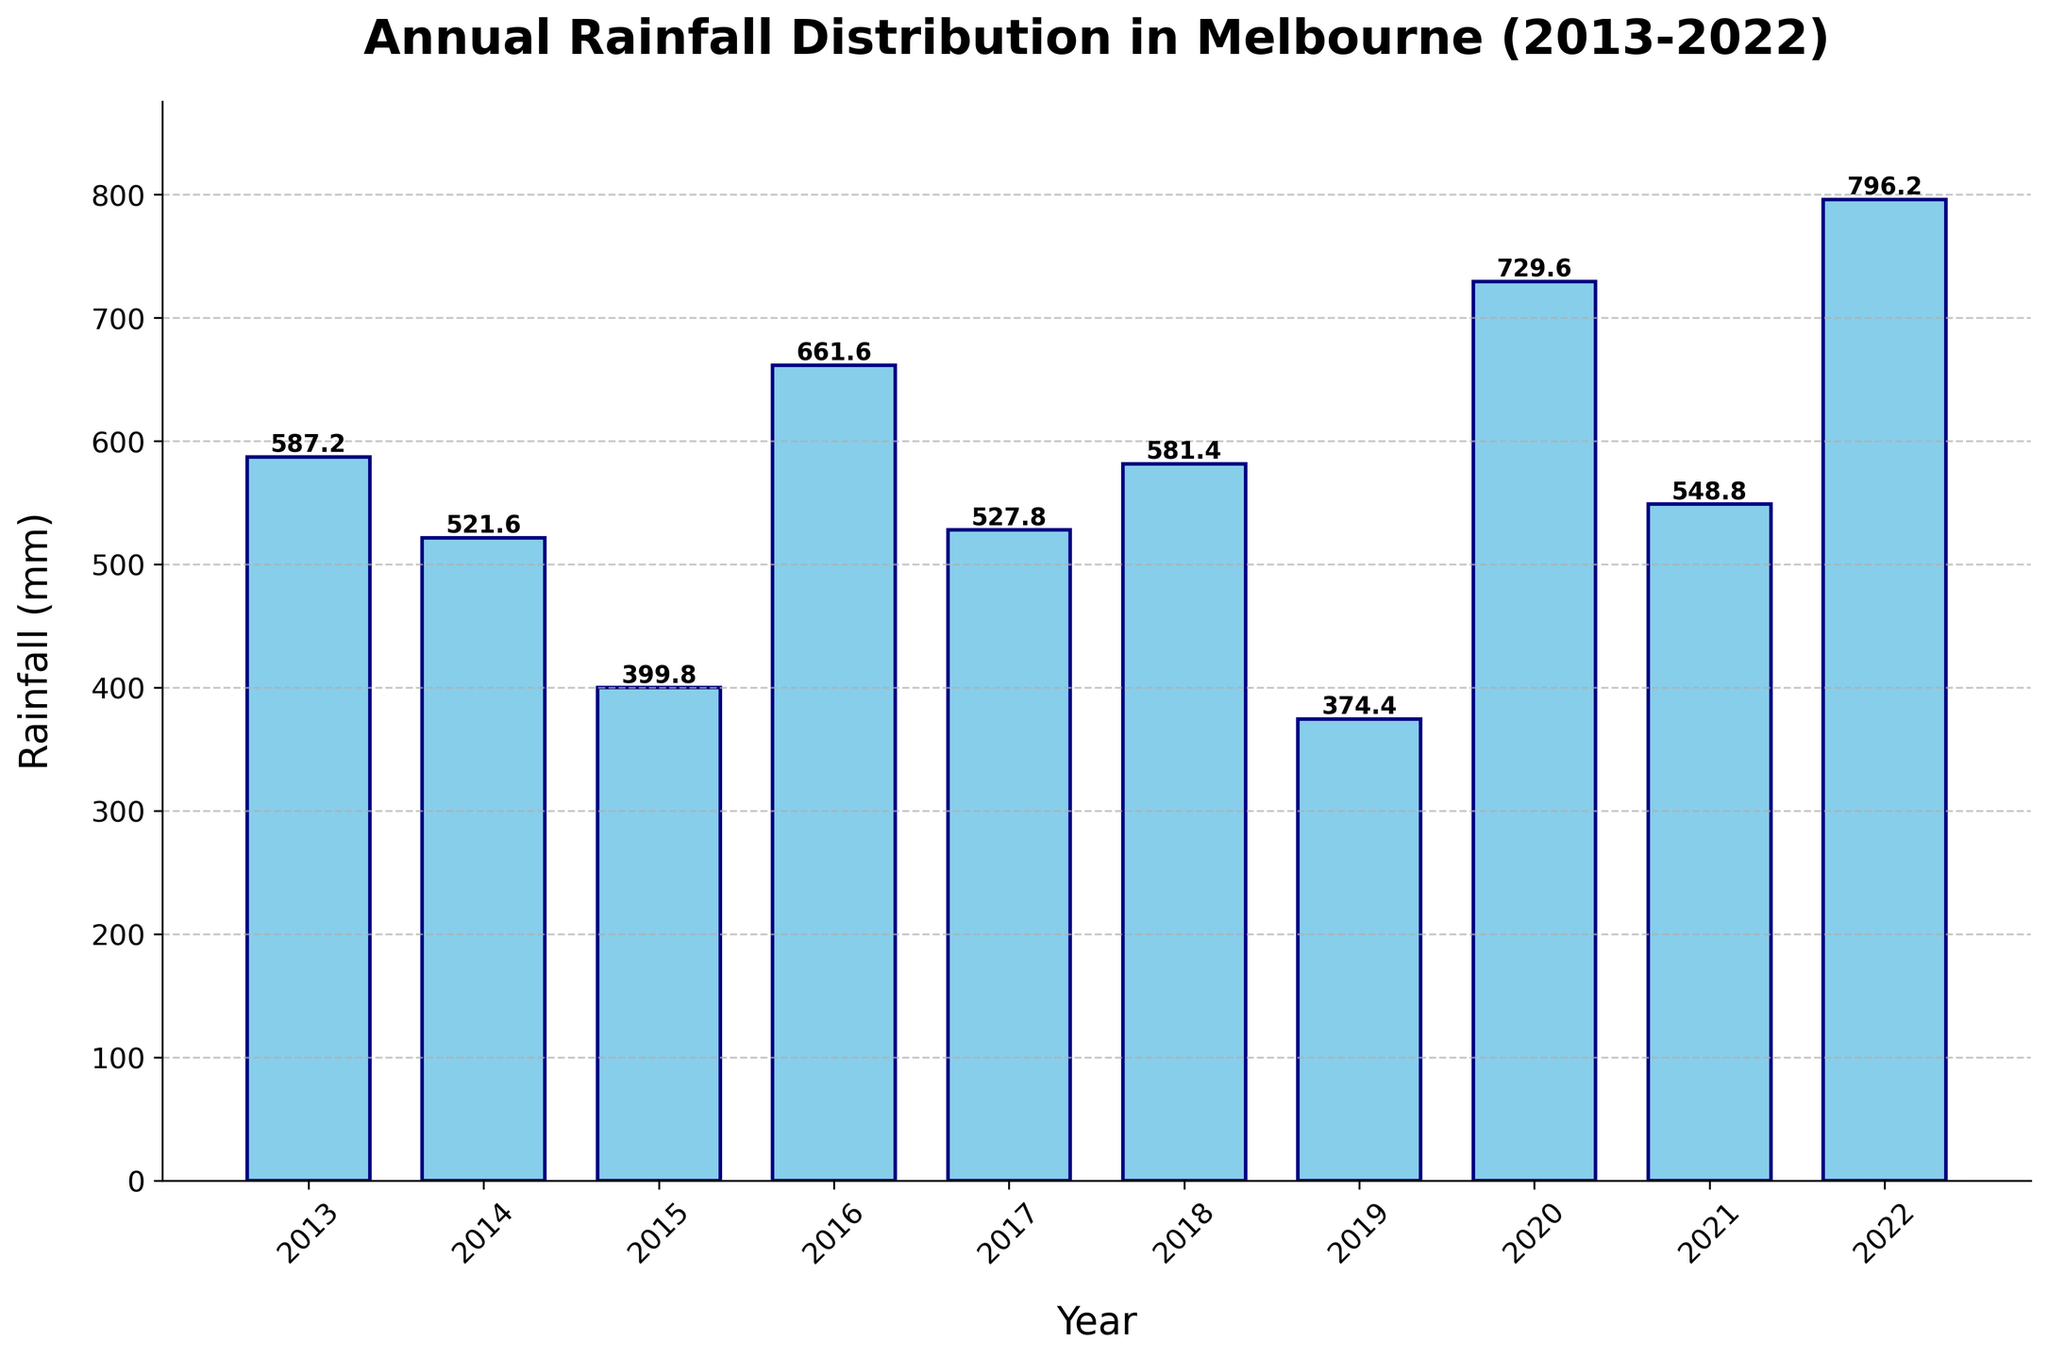What's the year with the highest annual rainfall? Identify the tallest bar, which represents the year 2022 with a value of 796.2 mm.
Answer: 2022 Which year had the lowest annual rainfall? Locate the shortest bar on the plot, which represents the year 2019 with a rainfall of 374.4 mm.
Answer: 2019 What is the total rainfall recorded over the past decade? Sum the values of rainfall for all years: 587.2 + 521.6 + 399.8 + 661.6 + 527.8 + 581.4 + 374.4 + 729.6 + 548.8 + 796.2 = 5728.4 mm.
Answer: 5728.4 mm What is the average annual rainfall from 2013 to 2022? Calculate the average by dividing the total rainfall by 10: 5728.4 mm / 10 years = 572.84 mm.
Answer: 572.8 mm Which year experienced more rainfall: 2016 or 2021? Compare the height of the bars for the years 2016 (661.6 mm) and 2021 (548.8 mm). 2016 has more rainfall.
Answer: 2016 What is the difference in rainfall between the year with the highest rainfall and the year with the lowest rainfall? Subtract the smallest value (374.4 mm in 2019) from the largest value (796.2 mm in 2022): 796.2 mm - 374.4 mm = 421.8 mm.
Answer: 421.8 mm How many years had a rainfall higher than 600 mm? Identify the years with bars taller than the 600 mm mark: 2016 (661.6 mm), 2020 (729.6 mm), 2022 (796.2 mm). There are 3 such years.
Answer: 3 Is there a trend towards increasing or decreasing rainfall over the decade? Comparing the heights of the bars over the years, there is no clear upward or downward trend. The rainfall values fluctuate significantly.
Answer: Fluctuating What’s the median annual rainfall value for the decade? Sorting the rainfall values in ascending order: 374.4, 399.8, 521.6, 527.8, 548.8, 581.4, 587.2, 661.6, 729.6, 796.2. The median is the average of the 5th and 6th values: (548.8 + 581.4) / 2 = 565.1 mm.
Answer: 565.1 mm How much more rainfall was there in the year with the highest rainfall compared to the average annual rainfall? Subtract the average rainfall from the highest rainfall: 796.2 mm - 572.84 mm ≈ 223.36 mm.
Answer: 223.4 mm 